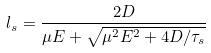Convert formula to latex. <formula><loc_0><loc_0><loc_500><loc_500>l _ { s } = \frac { 2 D } { \mu E + \sqrt { \mu ^ { 2 } E ^ { 2 } + 4 D / \tau _ { s } } }</formula> 